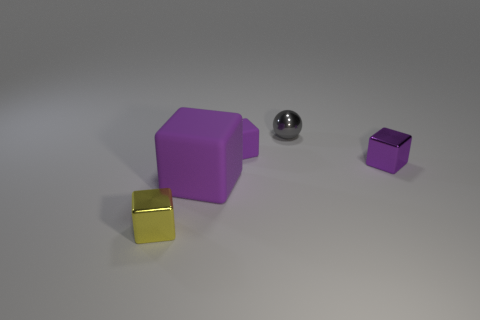Are the object that is behind the small purple rubber object and the small yellow block made of the same material?
Provide a short and direct response. Yes. Are there any small gray rubber cylinders?
Provide a succinct answer. No. What is the color of the tiny thing that is the same material as the large block?
Ensure brevity in your answer.  Purple. There is a metal object that is in front of the purple block that is in front of the tiny metallic cube behind the large matte block; what is its color?
Provide a short and direct response. Yellow. Do the metallic ball and the block to the right of the small shiny sphere have the same size?
Provide a succinct answer. Yes. How many things are either purple things that are behind the large purple block or small things that are on the right side of the tiny yellow shiny object?
Offer a very short reply. 3. What shape is the gray metal object that is the same size as the yellow block?
Ensure brevity in your answer.  Sphere. There is a tiny metal thing behind the purple matte thing behind the small shiny block that is right of the small yellow object; what shape is it?
Your answer should be compact. Sphere. Are there the same number of tiny purple metallic blocks on the right side of the tiny yellow cube and purple metallic things?
Offer a very short reply. Yes. Does the purple metal object have the same size as the yellow metallic object?
Make the answer very short. Yes. 